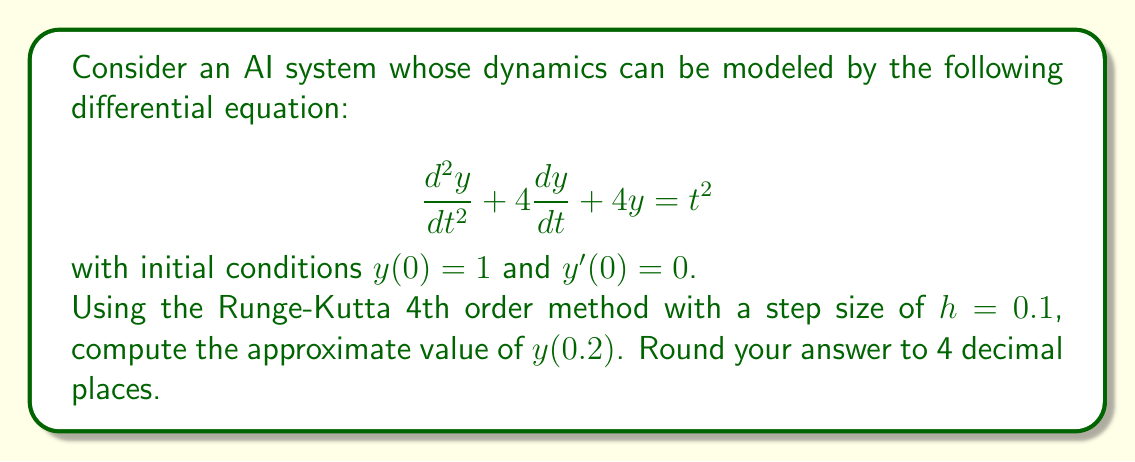Help me with this question. To solve this second-order differential equation numerically, we need to convert it into a system of first-order equations. Let $y_1 = y$ and $y_2 = y'$. Then:

$$\begin{align}
y_1' &= y_2 \\
y_2' &= t^2 - 4y_2 - 4y_1
\end{align}$$

Now we can apply the Runge-Kutta 4th order method:

$$\begin{align}
k_{1,i} &= hf_i(t_n, y_{1,n}, y_{2,n}) \\
k_{2,i} &= hf_i(t_n + \frac{h}{2}, y_{1,n} + \frac{k_{1,1}}{2}, y_{2,n} + \frac{k_{1,2}}{2}) \\
k_{3,i} &= hf_i(t_n + \frac{h}{2}, y_{1,n} + \frac{k_{2,1}}{2}, y_{2,n} + \frac{k_{2,2}}{2}) \\
k_{4,i} &= hf_i(t_n + h, y_{1,n} + k_{3,1}, y_{2,n} + k_{3,2}) \\
y_{i,n+1} &= y_{i,n} + \frac{1}{6}(k_{1,i} + 2k_{2,i} + 2k_{3,i} + k_{4,i})
\end{align}$$

where $i = 1, 2$ for each equation in our system.

Given:
- $h = 0.1$
- $y_1(0) = 1$
- $y_2(0) = 0$
- We need to compute $y(0.2)$, which means we need to perform 2 steps.

Step 1: $t_0 = 0$ to $t_1 = 0.1$

Calculate $k$ values:
$$\begin{align}
k_{1,1} &= 0.1 \cdot 0 = 0 \\
k_{1,2} &= 0.1 \cdot (0^2 - 4 \cdot 0 - 4 \cdot 1) = -0.4 \\
k_{2,1} &= 0.1 \cdot (-0.2) = -0.02 \\
k_{2,2} &= 0.1 \cdot (0.05^2 - 4 \cdot (-0.2) - 4 \cdot 0.99) = 0.0002475 \\
k_{3,1} &= 0.1 \cdot 0.0001238 = 0.00001238 \\
k_{3,2} &= 0.1 \cdot (0.05^2 - 4 \cdot 0.0001238 - 4 \cdot 0.99) = -0.3959505 \\
k_{4,1} &= 0.1 \cdot (-0.3959505) = -0.03959505 \\
k_{4,2} &= 0.1 \cdot (0.1^2 - 4 \cdot (-0.3959505) - 4 \cdot 0.96040495) = 1.5752525
\end{align}$$

Update $y_1$ and $y_2$:
$$\begin{align}
y_{1,1} &= 1 + \frac{1}{6}(0 - 0.04 + 0.00002476 - 0.03959505) = 0.9860342 \\
y_{2,1} &= 0 + \frac{1}{6}(-0.4 + 0.0004950 - 0.7919010 + 1.5752525) = 0.0639744
\end{align}$$

Step 2: $t_1 = 0.1$ to $t_2 = 0.2$

Repeat the process using $y_{1,1}$ and $y_{2,1}$ as initial values. After calculations:

$$\begin{align}
y_{1,2} &= 0.9935419 \\
y_{2,2} &= 0.1268352
\end{align}$$

The value of $y(0.2)$ is $y_{1,2} = 0.9935419$.
Answer: $y(0.2) \approx 0.9935$ 